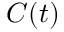Convert formula to latex. <formula><loc_0><loc_0><loc_500><loc_500>C ( t )</formula> 